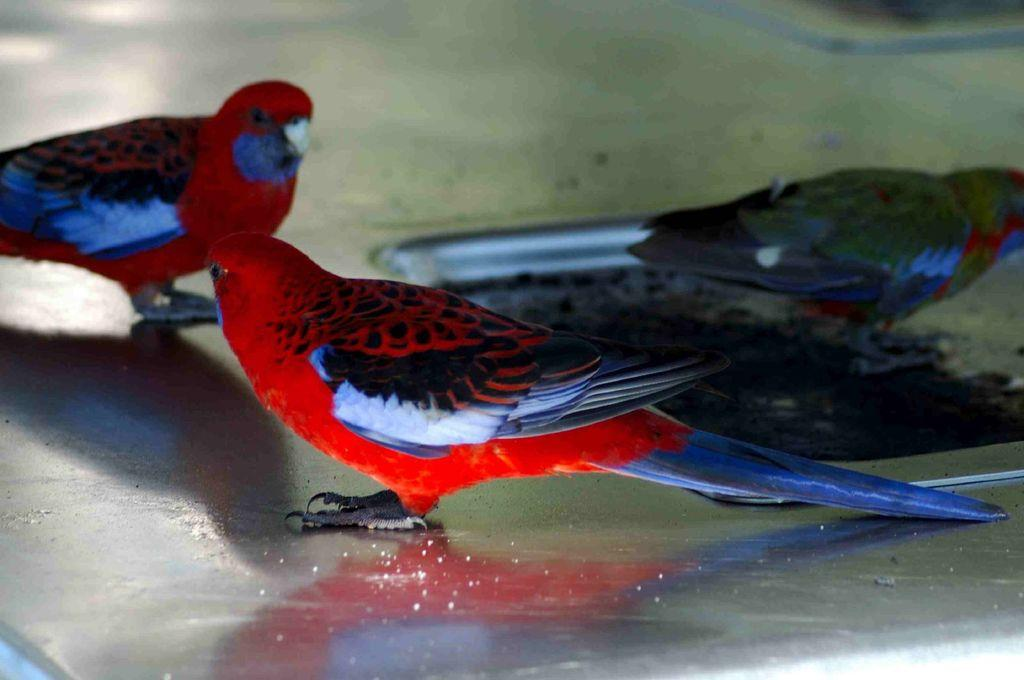What type of animals are in the image? There are three red color birds in the image. What color are the beaks of the birds? The birds have white beaks. Where are the birds located in the image? The birds are on the ground. How many tomatoes can be seen in the image? There are no tomatoes present in the image. What type of engine is visible in the image? There is no engine present in the image. 